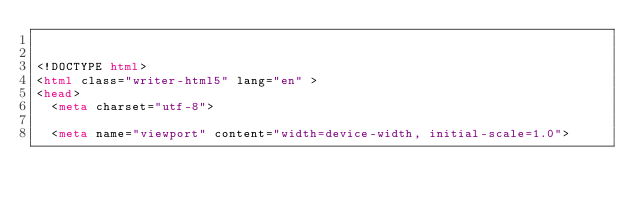<code> <loc_0><loc_0><loc_500><loc_500><_HTML_>

<!DOCTYPE html>
<html class="writer-html5" lang="en" >
<head>
  <meta charset="utf-8">
  
  <meta name="viewport" content="width=device-width, initial-scale=1.0">
  </code> 